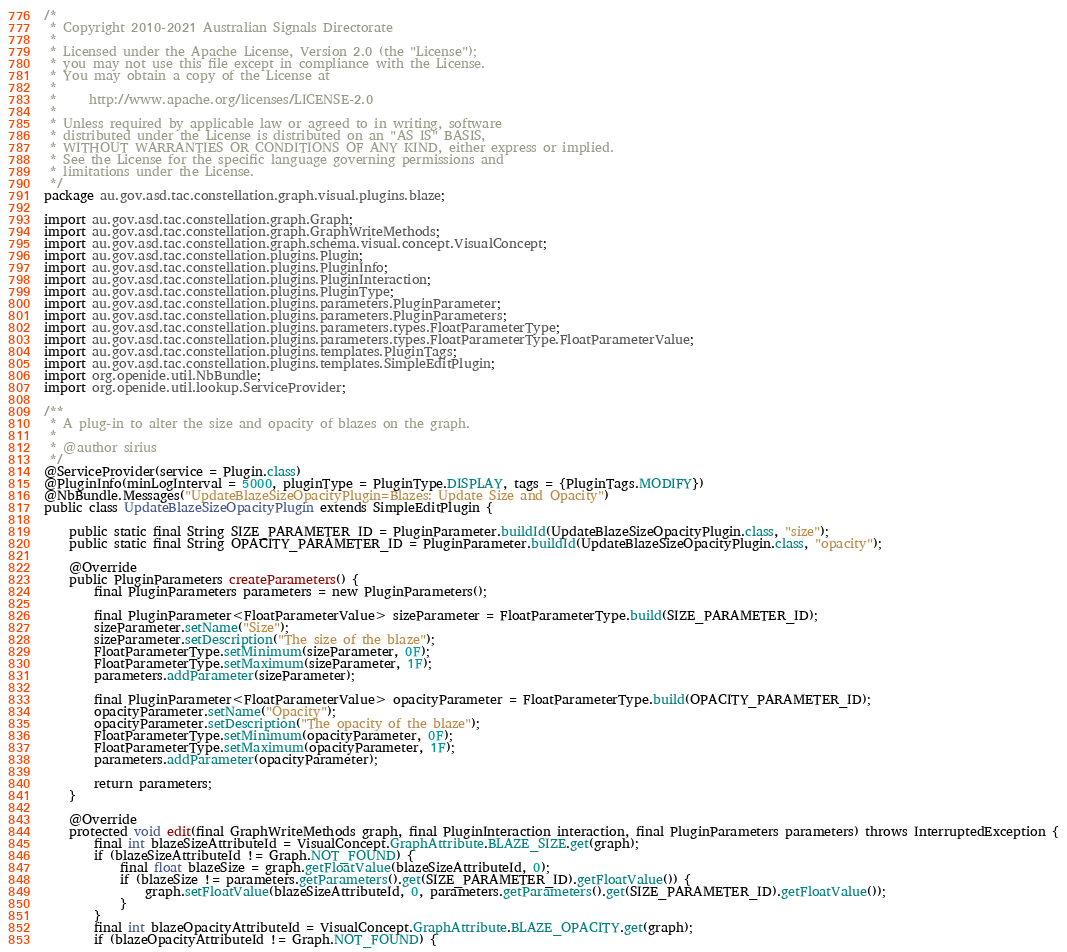Convert code to text. <code><loc_0><loc_0><loc_500><loc_500><_Java_>/*
 * Copyright 2010-2021 Australian Signals Directorate
 *
 * Licensed under the Apache License, Version 2.0 (the "License");
 * you may not use this file except in compliance with the License.
 * You may obtain a copy of the License at
 *
 *     http://www.apache.org/licenses/LICENSE-2.0
 *
 * Unless required by applicable law or agreed to in writing, software
 * distributed under the License is distributed on an "AS IS" BASIS,
 * WITHOUT WARRANTIES OR CONDITIONS OF ANY KIND, either express or implied.
 * See the License for the specific language governing permissions and
 * limitations under the License.
 */
package au.gov.asd.tac.constellation.graph.visual.plugins.blaze;

import au.gov.asd.tac.constellation.graph.Graph;
import au.gov.asd.tac.constellation.graph.GraphWriteMethods;
import au.gov.asd.tac.constellation.graph.schema.visual.concept.VisualConcept;
import au.gov.asd.tac.constellation.plugins.Plugin;
import au.gov.asd.tac.constellation.plugins.PluginInfo;
import au.gov.asd.tac.constellation.plugins.PluginInteraction;
import au.gov.asd.tac.constellation.plugins.PluginType;
import au.gov.asd.tac.constellation.plugins.parameters.PluginParameter;
import au.gov.asd.tac.constellation.plugins.parameters.PluginParameters;
import au.gov.asd.tac.constellation.plugins.parameters.types.FloatParameterType;
import au.gov.asd.tac.constellation.plugins.parameters.types.FloatParameterType.FloatParameterValue;
import au.gov.asd.tac.constellation.plugins.templates.PluginTags;
import au.gov.asd.tac.constellation.plugins.templates.SimpleEditPlugin;
import org.openide.util.NbBundle;
import org.openide.util.lookup.ServiceProvider;

/**
 * A plug-in to alter the size and opacity of blazes on the graph.
 *
 * @author sirius
 */
@ServiceProvider(service = Plugin.class)
@PluginInfo(minLogInterval = 5000, pluginType = PluginType.DISPLAY, tags = {PluginTags.MODIFY})
@NbBundle.Messages("UpdateBlazeSizeOpacityPlugin=Blazes: Update Size and Opacity")
public class UpdateBlazeSizeOpacityPlugin extends SimpleEditPlugin {

    public static final String SIZE_PARAMETER_ID = PluginParameter.buildId(UpdateBlazeSizeOpacityPlugin.class, "size");
    public static final String OPACITY_PARAMETER_ID = PluginParameter.buildId(UpdateBlazeSizeOpacityPlugin.class, "opacity");

    @Override
    public PluginParameters createParameters() {
        final PluginParameters parameters = new PluginParameters();

        final PluginParameter<FloatParameterValue> sizeParameter = FloatParameterType.build(SIZE_PARAMETER_ID);
        sizeParameter.setName("Size");
        sizeParameter.setDescription("The size of the blaze");
        FloatParameterType.setMinimum(sizeParameter, 0F);
        FloatParameterType.setMaximum(sizeParameter, 1F);
        parameters.addParameter(sizeParameter);

        final PluginParameter<FloatParameterValue> opacityParameter = FloatParameterType.build(OPACITY_PARAMETER_ID);
        opacityParameter.setName("Opacity");
        opacityParameter.setDescription("The opacity of the blaze");
        FloatParameterType.setMinimum(opacityParameter, 0F);
        FloatParameterType.setMaximum(opacityParameter, 1F);
        parameters.addParameter(opacityParameter);

        return parameters;
    }

    @Override
    protected void edit(final GraphWriteMethods graph, final PluginInteraction interaction, final PluginParameters parameters) throws InterruptedException {
        final int blazeSizeAttributeId = VisualConcept.GraphAttribute.BLAZE_SIZE.get(graph);
        if (blazeSizeAttributeId != Graph.NOT_FOUND) {
            final float blazeSize = graph.getFloatValue(blazeSizeAttributeId, 0);
            if (blazeSize != parameters.getParameters().get(SIZE_PARAMETER_ID).getFloatValue()) {
                graph.setFloatValue(blazeSizeAttributeId, 0, parameters.getParameters().get(SIZE_PARAMETER_ID).getFloatValue());
            }
        }
        final int blazeOpacityAttributeId = VisualConcept.GraphAttribute.BLAZE_OPACITY.get(graph);
        if (blazeOpacityAttributeId != Graph.NOT_FOUND) {</code> 